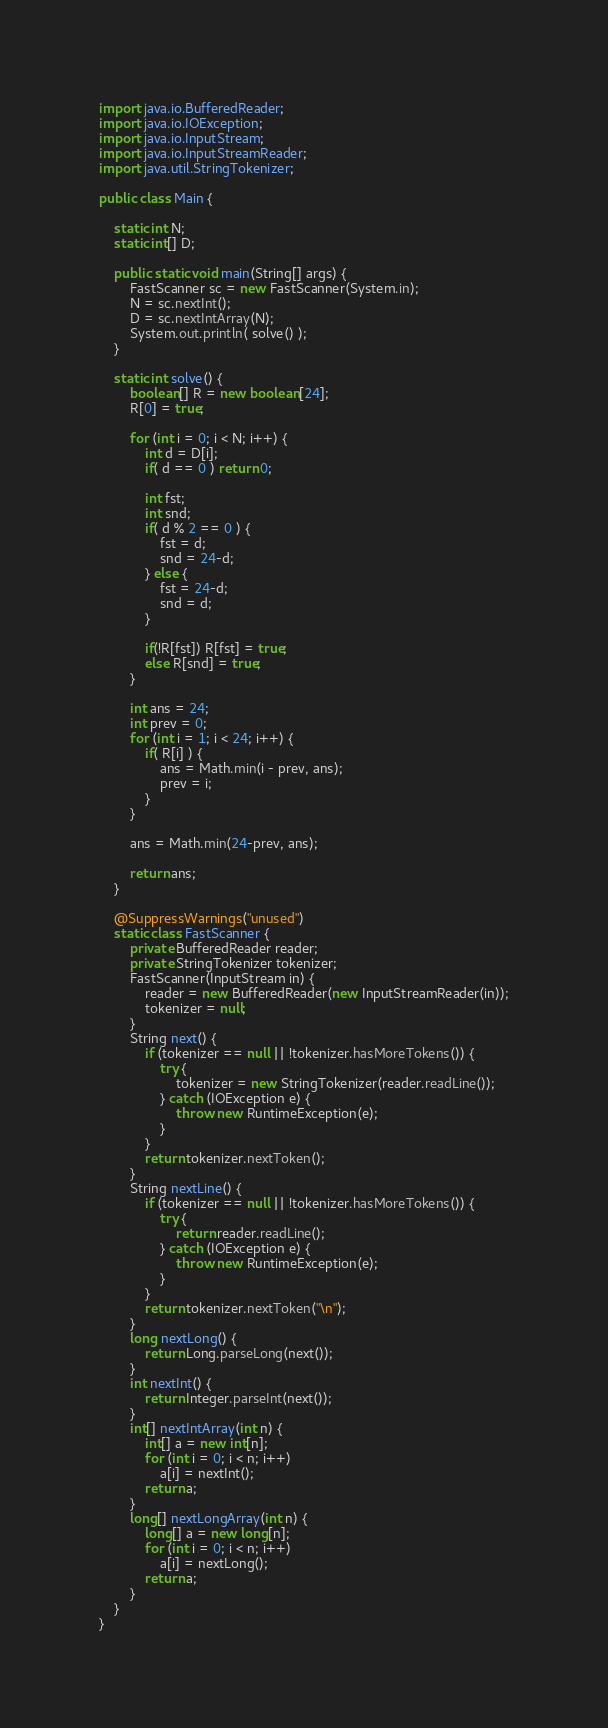Convert code to text. <code><loc_0><loc_0><loc_500><loc_500><_Java_>import java.io.BufferedReader;
import java.io.IOException;
import java.io.InputStream;
import java.io.InputStreamReader;
import java.util.StringTokenizer;

public class Main {

    static int N;
    static int[] D;

    public static void main(String[] args) {
        FastScanner sc = new FastScanner(System.in);
        N = sc.nextInt();
        D = sc.nextIntArray(N);
        System.out.println( solve() );
    }

    static int solve() {
        boolean[] R = new boolean[24];
        R[0] = true;

        for (int i = 0; i < N; i++) {
            int d = D[i];
            if( d == 0 ) return 0;

            int fst;
            int snd;
            if( d % 2 == 0 ) {
                fst = d;
                snd = 24-d;
            } else {
                fst = 24-d;
                snd = d;
            }

            if(!R[fst]) R[fst] = true;
            else R[snd] = true;
        }

        int ans = 24;
        int prev = 0;
        for (int i = 1; i < 24; i++) {
            if( R[i] ) {
                ans = Math.min(i - prev, ans);
                prev = i;
            }
        }
        
        ans = Math.min(24-prev, ans);

        return ans;
    }

    @SuppressWarnings("unused")
    static class FastScanner {
        private BufferedReader reader;
        private StringTokenizer tokenizer;
        FastScanner(InputStream in) {
            reader = new BufferedReader(new InputStreamReader(in));
            tokenizer = null;
        }
        String next() {
            if (tokenizer == null || !tokenizer.hasMoreTokens()) {
                try {
                    tokenizer = new StringTokenizer(reader.readLine());
                } catch (IOException e) {
                    throw new RuntimeException(e);
                }
            }
            return tokenizer.nextToken();
        }
        String nextLine() {
            if (tokenizer == null || !tokenizer.hasMoreTokens()) {
                try {
                    return reader.readLine();
                } catch (IOException e) {
                    throw new RuntimeException(e);
                }
            }
            return tokenizer.nextToken("\n");
        }
        long nextLong() {
            return Long.parseLong(next());
        }
        int nextInt() {
            return Integer.parseInt(next());
        }
        int[] nextIntArray(int n) {
            int[] a = new int[n];
            for (int i = 0; i < n; i++)
                a[i] = nextInt();
            return a;
        }
        long[] nextLongArray(int n) {
            long[] a = new long[n];
            for (int i = 0; i < n; i++)
                a[i] = nextLong();
            return a;
        }
    }
}</code> 